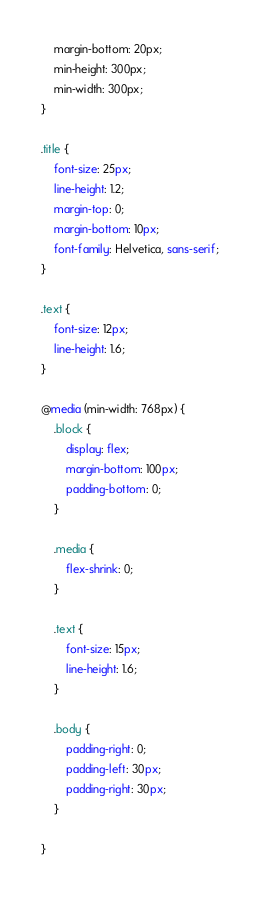Convert code to text. <code><loc_0><loc_0><loc_500><loc_500><_CSS_>    margin-bottom: 20px;
    min-height: 300px;
    min-width: 300px;
}

.title {
    font-size: 25px;
    line-height: 1.2;
    margin-top: 0;
    margin-bottom: 10px;
    font-family: Helvetica, sans-serif;
}

.text {
    font-size: 12px;
    line-height: 1.6;
}

@media (min-width: 768px) {
    .block {
        display: flex;
        margin-bottom: 100px;
        padding-bottom: 0;
    }

    .media {
        flex-shrink: 0;
    }

    .text {
        font-size: 15px;
        line-height: 1.6;
    }

    .body {
        padding-right: 0;
        padding-left: 30px;
        padding-right: 30px;
    }

}</code> 